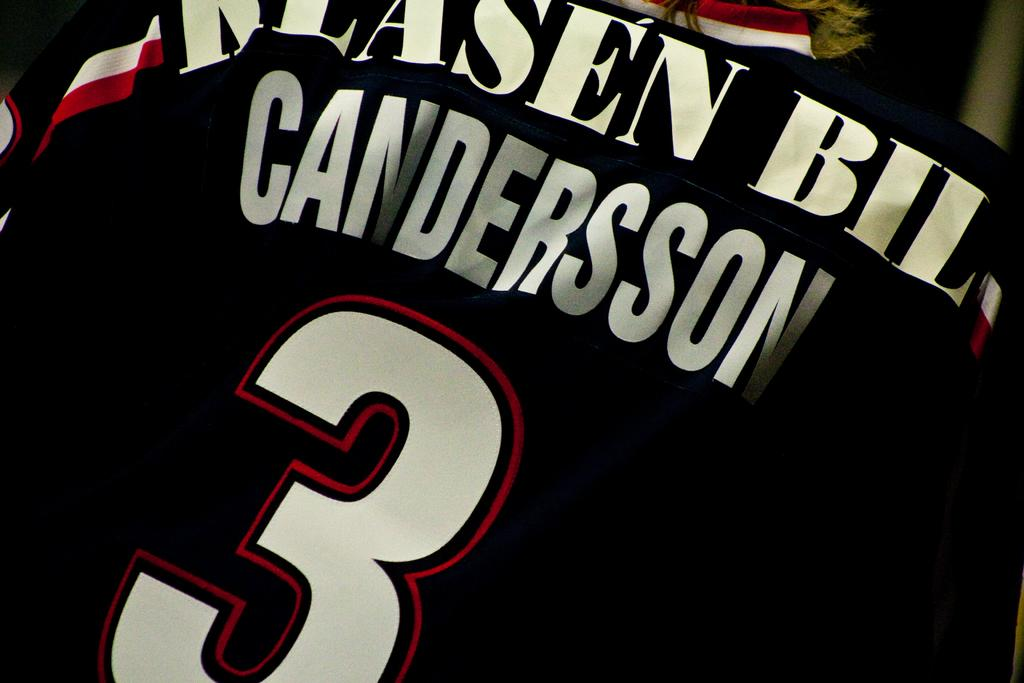<image>
Provide a brief description of the given image. Upon this shirt you can read a Candersson. 